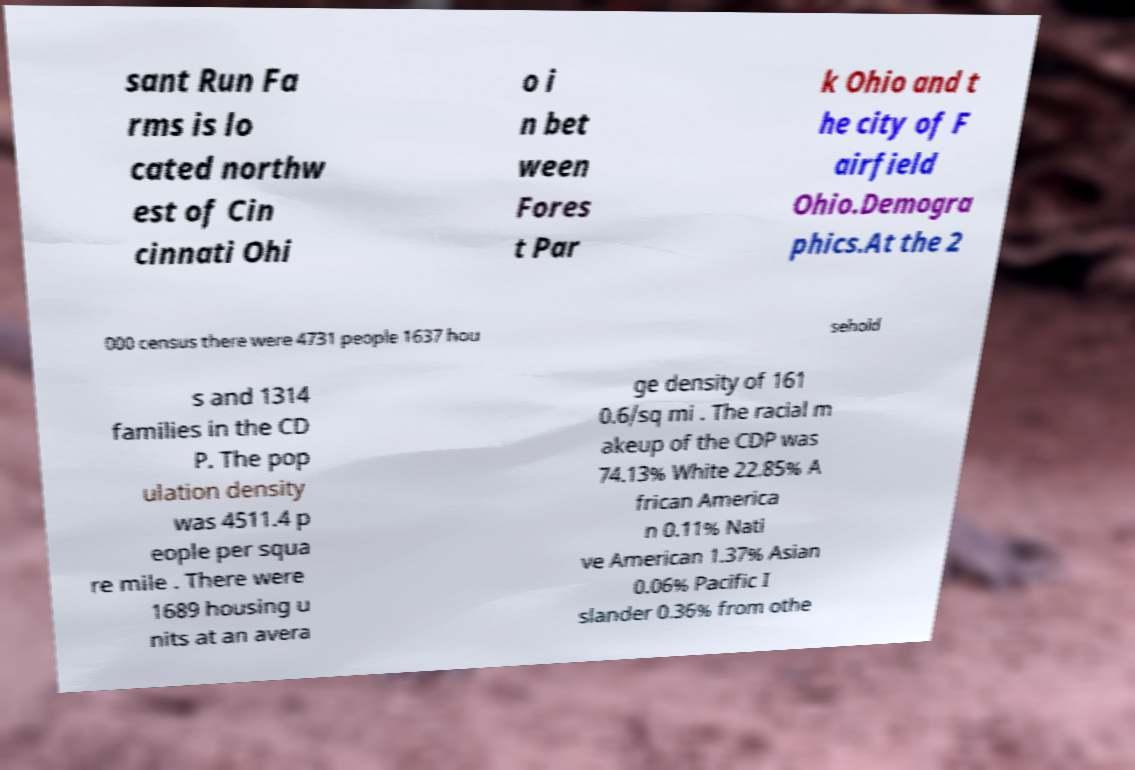For documentation purposes, I need the text within this image transcribed. Could you provide that? sant Run Fa rms is lo cated northw est of Cin cinnati Ohi o i n bet ween Fores t Par k Ohio and t he city of F airfield Ohio.Demogra phics.At the 2 000 census there were 4731 people 1637 hou sehold s and 1314 families in the CD P. The pop ulation density was 4511.4 p eople per squa re mile . There were 1689 housing u nits at an avera ge density of 161 0.6/sq mi . The racial m akeup of the CDP was 74.13% White 22.85% A frican America n 0.11% Nati ve American 1.37% Asian 0.06% Pacific I slander 0.36% from othe 